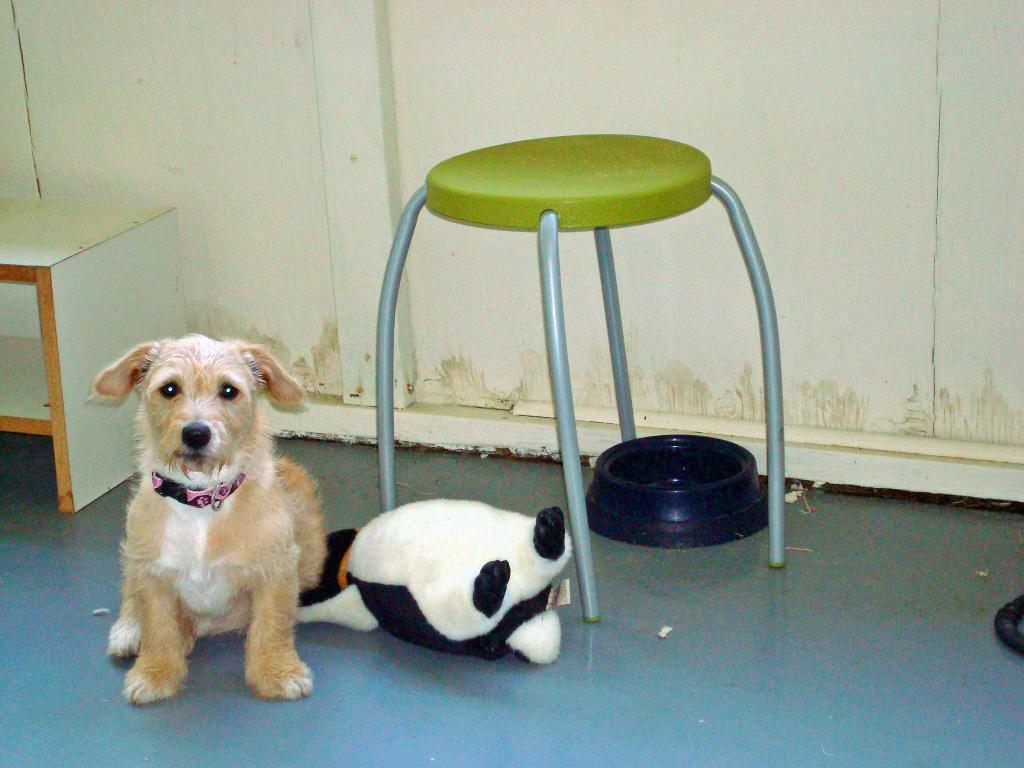Can you describe this image briefly? In this image there is one dog is sitting on the floor at left side of this image and there is a toy at bottom of this image and there is a table in middle of this image and there is a wall in the background. 